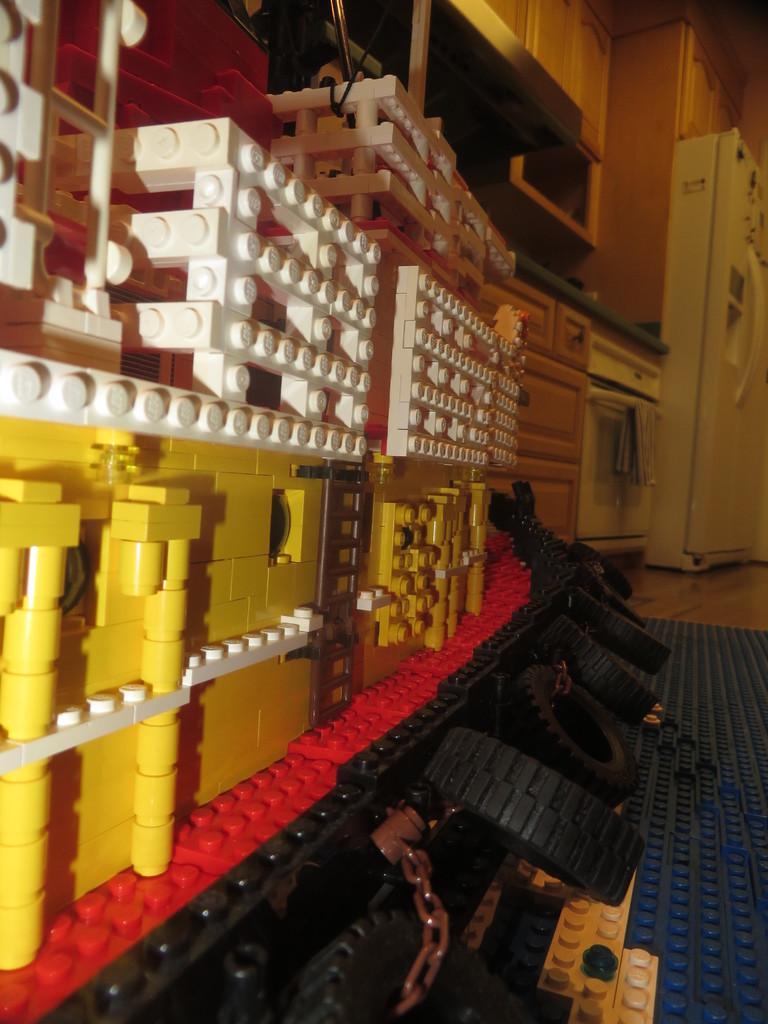Could you give a brief overview of what you see in this image? In this image I can see a structure which is made of lego which is cream, red, yellow, black and blue in color. In the background I can see a refrigerator which is white in color, few cabinets, few drawers, a oven and the counter top of the kitchen. 